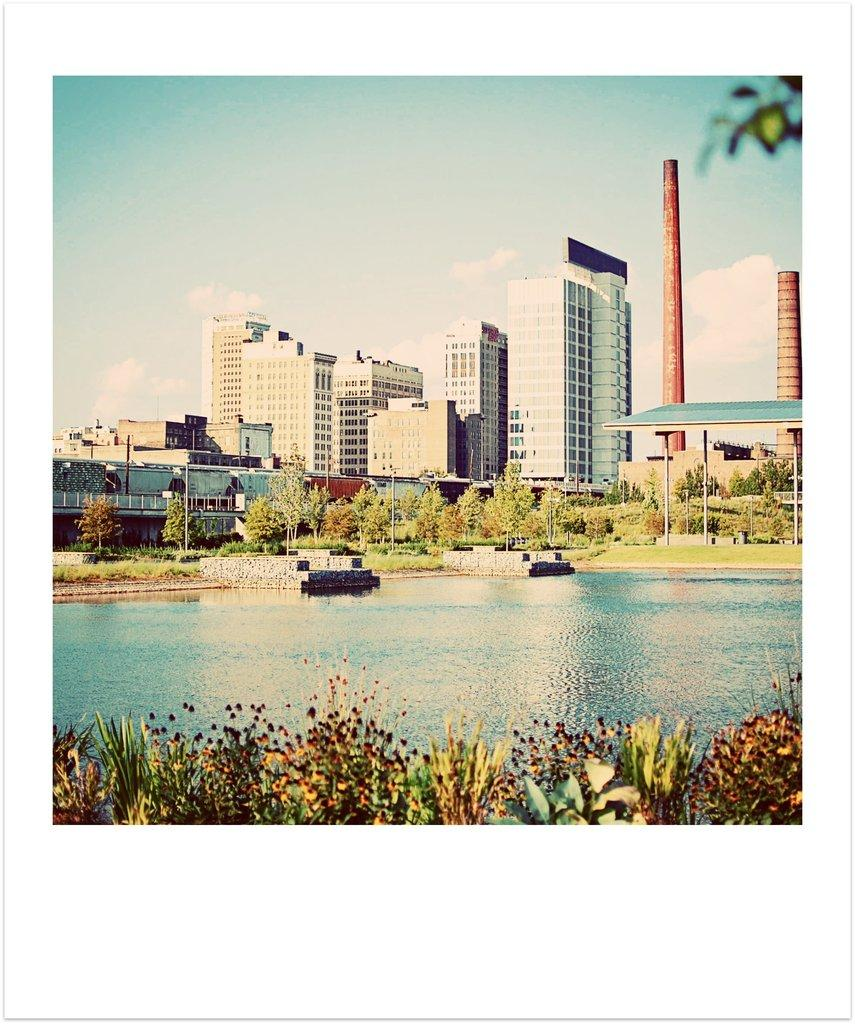What is present in the image that is not solid? There is water in the image. What type of vegetation can be seen in the image? There are plants and trees in the image. What can be seen in the distance in the image? There are buildings and red towers in the background of the image. What part of the natural environment is visible in the image? The sky is visible in the image. How many nuts are visible in the image? There are no nuts present in the image. Can you tell me what type of ticket the boy is holding in the image? There is no boy or ticket present in the image. 